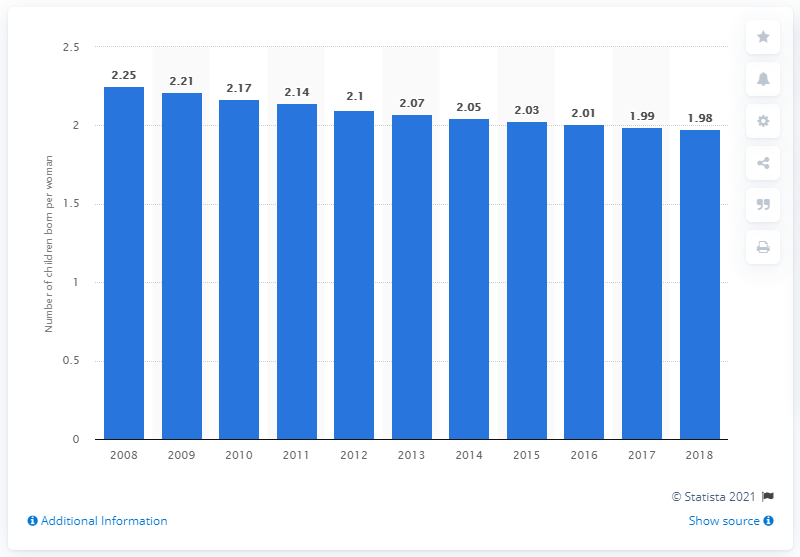Outline some significant characteristics in this image. In 2018, Jamaica's fertility rate was 1.98. 